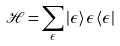<formula> <loc_0><loc_0><loc_500><loc_500>\mathcal { H } = \sum _ { \epsilon } | \epsilon \rangle \, \epsilon \, \langle \epsilon |</formula> 